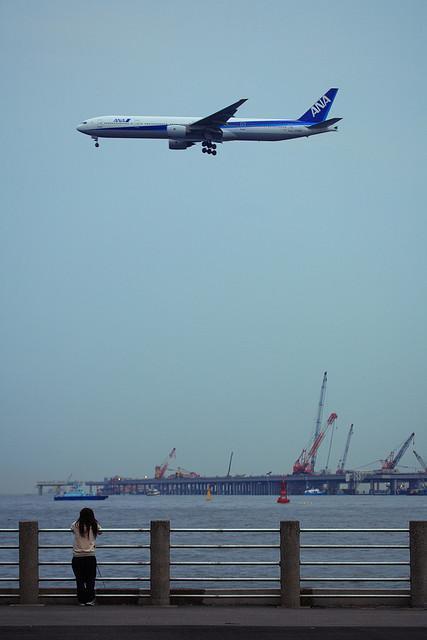From what country does ANA hail from?
Choose the correct response and explain in the format: 'Answer: answer
Rationale: rationale.'
Options: Sweden, japan, norway, france. Answer: japan.
Rationale: According to google it is located in japan. 